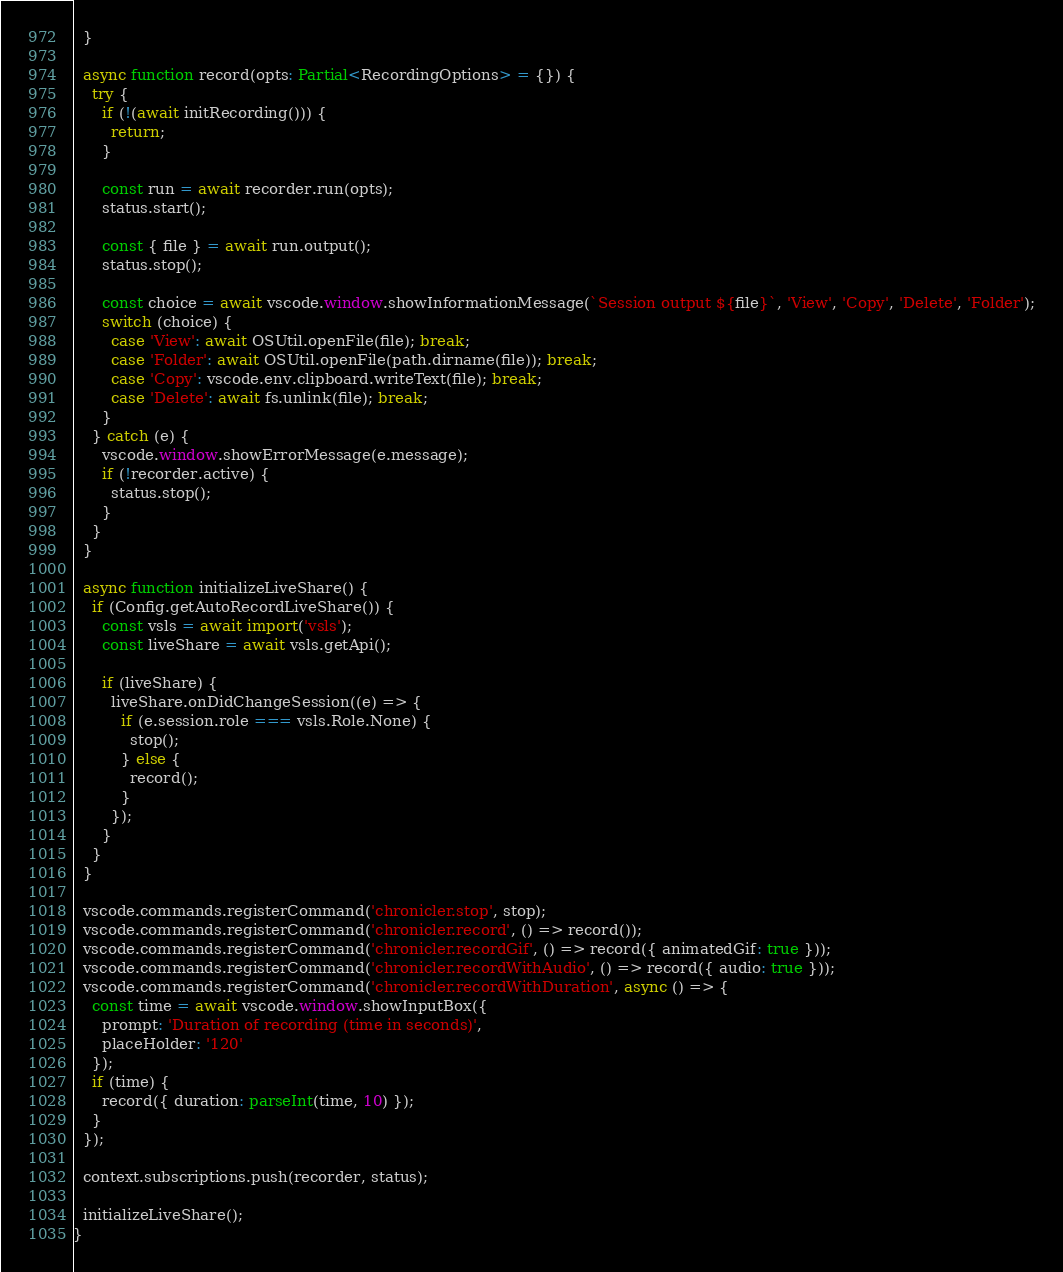Convert code to text. <code><loc_0><loc_0><loc_500><loc_500><_TypeScript_>  }

  async function record(opts: Partial<RecordingOptions> = {}) {
    try {
      if (!(await initRecording())) {
        return;
      }

      const run = await recorder.run(opts);
      status.start();

      const { file } = await run.output();
      status.stop();

      const choice = await vscode.window.showInformationMessage(`Session output ${file}`, 'View', 'Copy', 'Delete', 'Folder');
      switch (choice) {
        case 'View': await OSUtil.openFile(file); break;
        case 'Folder': await OSUtil.openFile(path.dirname(file)); break;
        case 'Copy': vscode.env.clipboard.writeText(file); break;
        case 'Delete': await fs.unlink(file); break;
      }
    } catch (e) {
      vscode.window.showErrorMessage(e.message);
      if (!recorder.active) {
        status.stop();
      }
    }
  }

  async function initializeLiveShare() {
    if (Config.getAutoRecordLiveShare()) {
      const vsls = await import('vsls');
      const liveShare = await vsls.getApi();

      if (liveShare) {
        liveShare.onDidChangeSession((e) => {
          if (e.session.role === vsls.Role.None) {
            stop();
          } else {
            record();
          }
        });
      }
    }
  }

  vscode.commands.registerCommand('chronicler.stop', stop);
  vscode.commands.registerCommand('chronicler.record', () => record());
  vscode.commands.registerCommand('chronicler.recordGif', () => record({ animatedGif: true }));
  vscode.commands.registerCommand('chronicler.recordWithAudio', () => record({ audio: true }));
  vscode.commands.registerCommand('chronicler.recordWithDuration', async () => {
    const time = await vscode.window.showInputBox({
      prompt: 'Duration of recording (time in seconds)',
      placeHolder: '120'
    });
    if (time) {
      record({ duration: parseInt(time, 10) });
    }
  });

  context.subscriptions.push(recorder, status);

  initializeLiveShare();
}</code> 